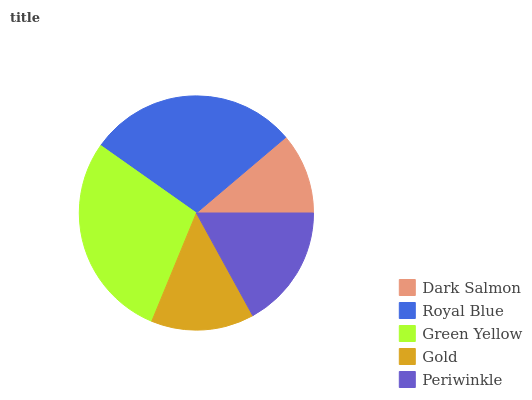Is Dark Salmon the minimum?
Answer yes or no. Yes. Is Royal Blue the maximum?
Answer yes or no. Yes. Is Green Yellow the minimum?
Answer yes or no. No. Is Green Yellow the maximum?
Answer yes or no. No. Is Royal Blue greater than Green Yellow?
Answer yes or no. Yes. Is Green Yellow less than Royal Blue?
Answer yes or no. Yes. Is Green Yellow greater than Royal Blue?
Answer yes or no. No. Is Royal Blue less than Green Yellow?
Answer yes or no. No. Is Periwinkle the high median?
Answer yes or no. Yes. Is Periwinkle the low median?
Answer yes or no. Yes. Is Royal Blue the high median?
Answer yes or no. No. Is Green Yellow the low median?
Answer yes or no. No. 